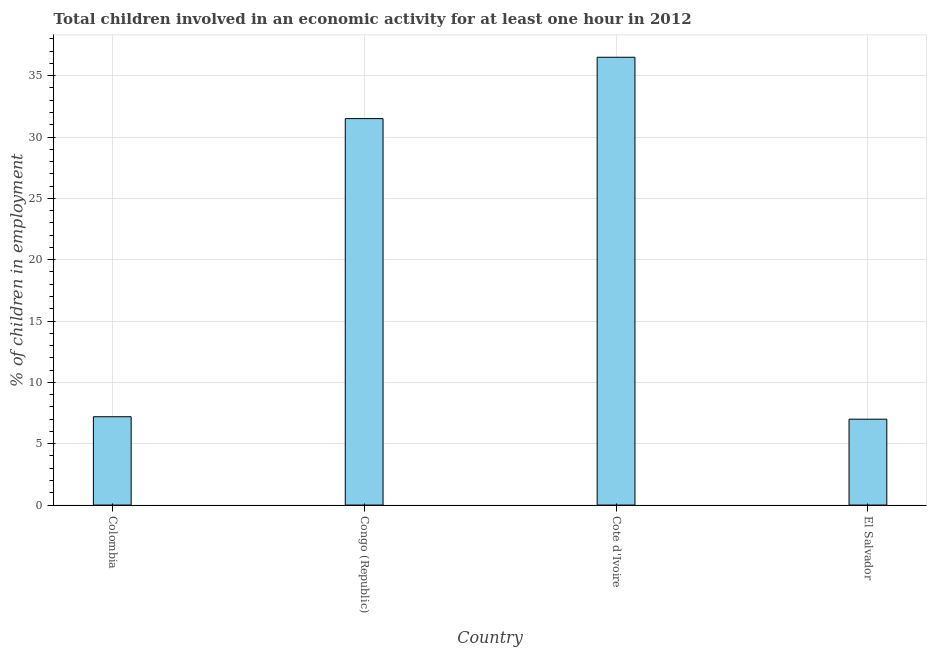Does the graph contain any zero values?
Provide a succinct answer. No. Does the graph contain grids?
Give a very brief answer. Yes. What is the title of the graph?
Provide a short and direct response. Total children involved in an economic activity for at least one hour in 2012. What is the label or title of the Y-axis?
Your answer should be very brief. % of children in employment. What is the percentage of children in employment in Colombia?
Your answer should be compact. 7.2. Across all countries, what is the maximum percentage of children in employment?
Provide a succinct answer. 36.5. In which country was the percentage of children in employment maximum?
Provide a succinct answer. Cote d'Ivoire. In which country was the percentage of children in employment minimum?
Give a very brief answer. El Salvador. What is the sum of the percentage of children in employment?
Give a very brief answer. 82.2. What is the difference between the percentage of children in employment in Congo (Republic) and El Salvador?
Offer a very short reply. 24.5. What is the average percentage of children in employment per country?
Provide a succinct answer. 20.55. What is the median percentage of children in employment?
Offer a terse response. 19.35. In how many countries, is the percentage of children in employment greater than 25 %?
Offer a terse response. 2. What is the ratio of the percentage of children in employment in Congo (Republic) to that in Cote d'Ivoire?
Ensure brevity in your answer.  0.86. Is the percentage of children in employment in Cote d'Ivoire less than that in El Salvador?
Offer a very short reply. No. Is the difference between the percentage of children in employment in Congo (Republic) and Cote d'Ivoire greater than the difference between any two countries?
Provide a succinct answer. No. What is the difference between the highest and the second highest percentage of children in employment?
Offer a terse response. 5. What is the difference between the highest and the lowest percentage of children in employment?
Your response must be concise. 29.5. How many bars are there?
Keep it short and to the point. 4. Are all the bars in the graph horizontal?
Ensure brevity in your answer.  No. How many countries are there in the graph?
Provide a short and direct response. 4. Are the values on the major ticks of Y-axis written in scientific E-notation?
Keep it short and to the point. No. What is the % of children in employment of Colombia?
Your answer should be compact. 7.2. What is the % of children in employment in Congo (Republic)?
Offer a terse response. 31.5. What is the % of children in employment of Cote d'Ivoire?
Your response must be concise. 36.5. What is the difference between the % of children in employment in Colombia and Congo (Republic)?
Offer a very short reply. -24.3. What is the difference between the % of children in employment in Colombia and Cote d'Ivoire?
Give a very brief answer. -29.3. What is the difference between the % of children in employment in Colombia and El Salvador?
Your answer should be very brief. 0.2. What is the difference between the % of children in employment in Cote d'Ivoire and El Salvador?
Your answer should be compact. 29.5. What is the ratio of the % of children in employment in Colombia to that in Congo (Republic)?
Give a very brief answer. 0.23. What is the ratio of the % of children in employment in Colombia to that in Cote d'Ivoire?
Provide a short and direct response. 0.2. What is the ratio of the % of children in employment in Colombia to that in El Salvador?
Keep it short and to the point. 1.03. What is the ratio of the % of children in employment in Congo (Republic) to that in Cote d'Ivoire?
Ensure brevity in your answer.  0.86. What is the ratio of the % of children in employment in Cote d'Ivoire to that in El Salvador?
Give a very brief answer. 5.21. 